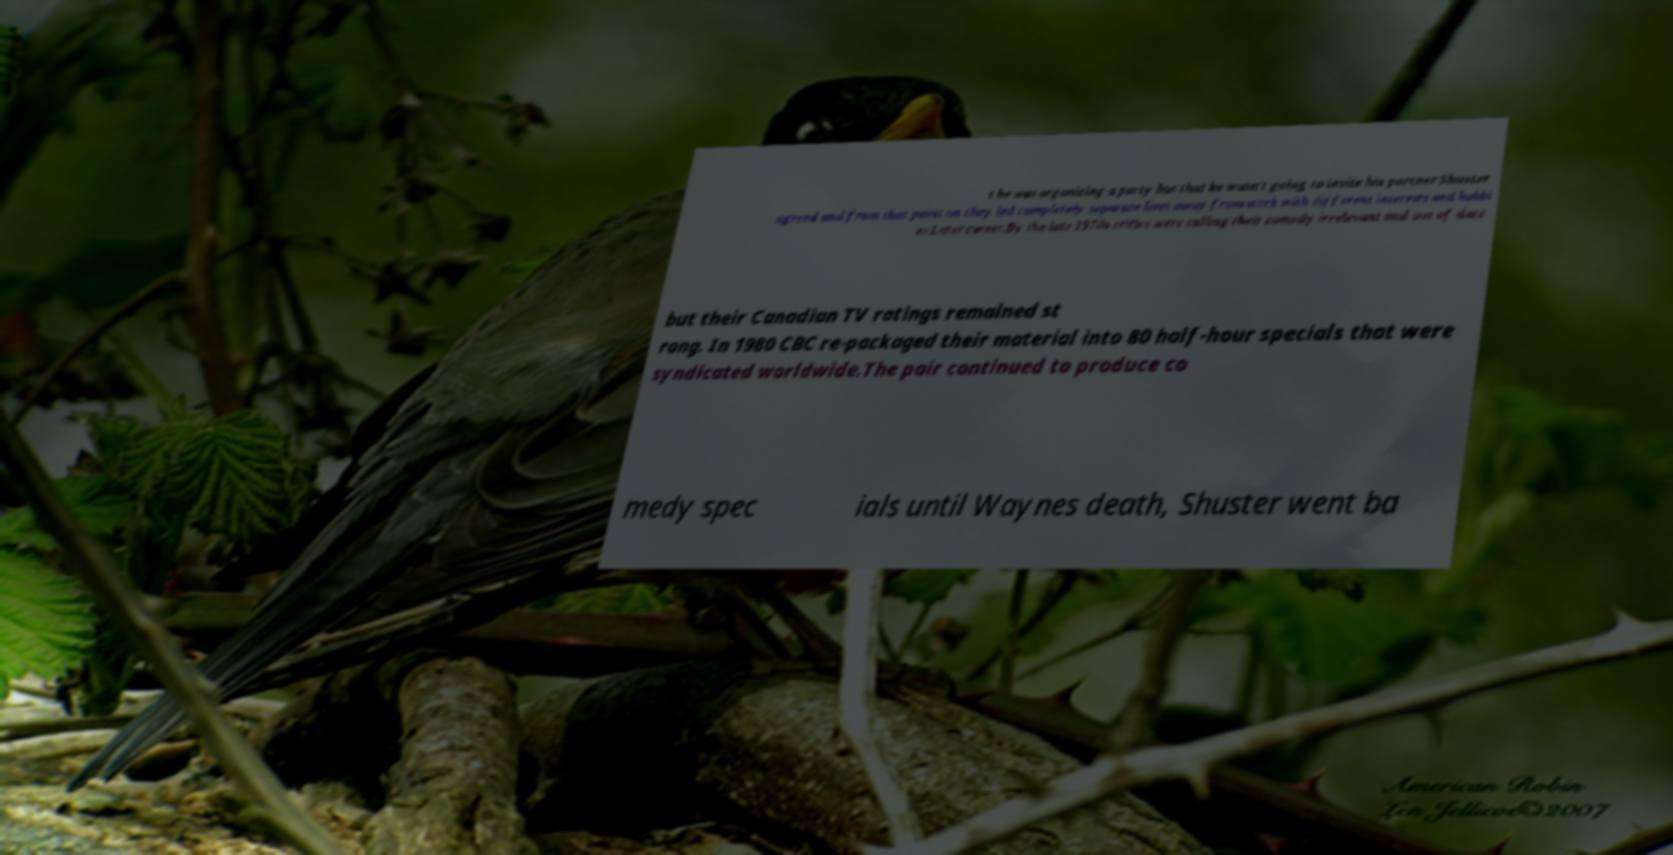Please read and relay the text visible in this image. What does it say? t he was organizing a party but that he wasn't going to invite his partner Shuster agreed and from that point on they led completely separate lives away from work with different interests and hobbi es.Later career.By the late 1970s critics were calling their comedy irrelevant and out of date but their Canadian TV ratings remained st rong. In 1980 CBC re-packaged their material into 80 half-hour specials that were syndicated worldwide.The pair continued to produce co medy spec ials until Waynes death, Shuster went ba 